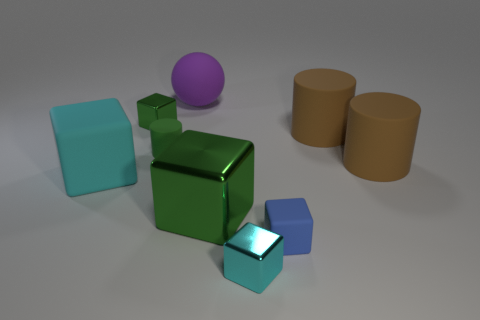Subtract all matte blocks. How many blocks are left? 3 Subtract all cyan blocks. How many blocks are left? 3 Subtract all red cubes. Subtract all purple spheres. How many cubes are left? 5 Add 1 tiny yellow spheres. How many objects exist? 10 Subtract all spheres. How many objects are left? 8 Subtract 0 yellow balls. How many objects are left? 9 Subtract all tiny cyan blocks. Subtract all big cyan shiny spheres. How many objects are left? 8 Add 5 small cylinders. How many small cylinders are left? 6 Add 3 small cylinders. How many small cylinders exist? 4 